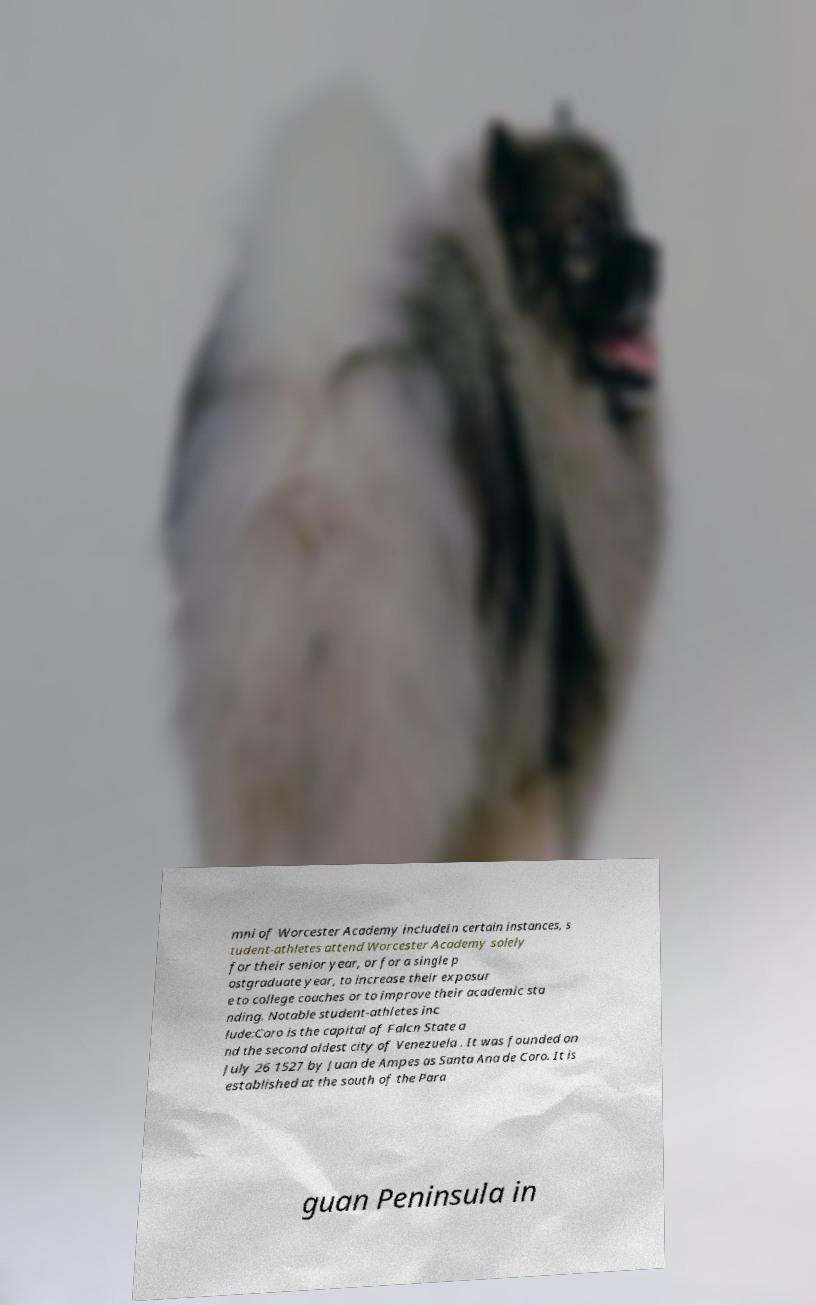Could you assist in decoding the text presented in this image and type it out clearly? mni of Worcester Academy includeIn certain instances, s tudent-athletes attend Worcester Academy solely for their senior year, or for a single p ostgraduate year, to increase their exposur e to college coaches or to improve their academic sta nding. Notable student-athletes inc lude:Coro is the capital of Falcn State a nd the second oldest city of Venezuela . It was founded on July 26 1527 by Juan de Ampes as Santa Ana de Coro. It is established at the south of the Para guan Peninsula in 